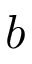Convert formula to latex. <formula><loc_0><loc_0><loc_500><loc_500>b</formula> 